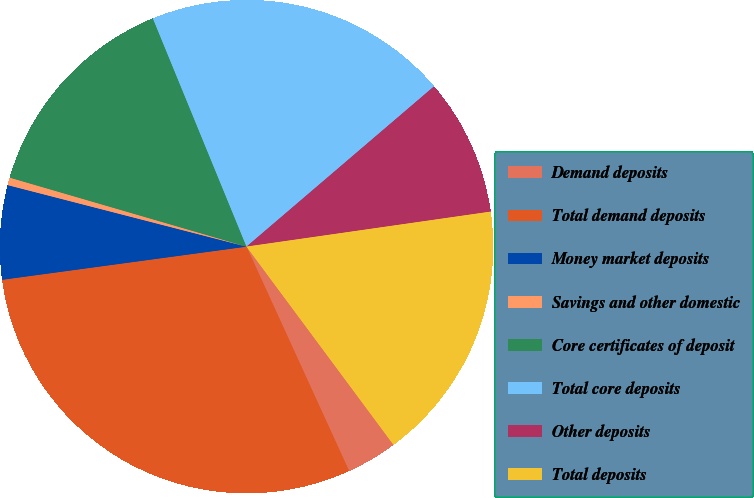Convert chart. <chart><loc_0><loc_0><loc_500><loc_500><pie_chart><fcel>Demand deposits<fcel>Total demand deposits<fcel>Money market deposits<fcel>Savings and other domestic<fcel>Core certificates of deposit<fcel>Total core deposits<fcel>Other deposits<fcel>Total deposits<nl><fcel>3.33%<fcel>29.68%<fcel>6.16%<fcel>0.5%<fcel>14.29%<fcel>19.94%<fcel>8.99%<fcel>17.11%<nl></chart> 